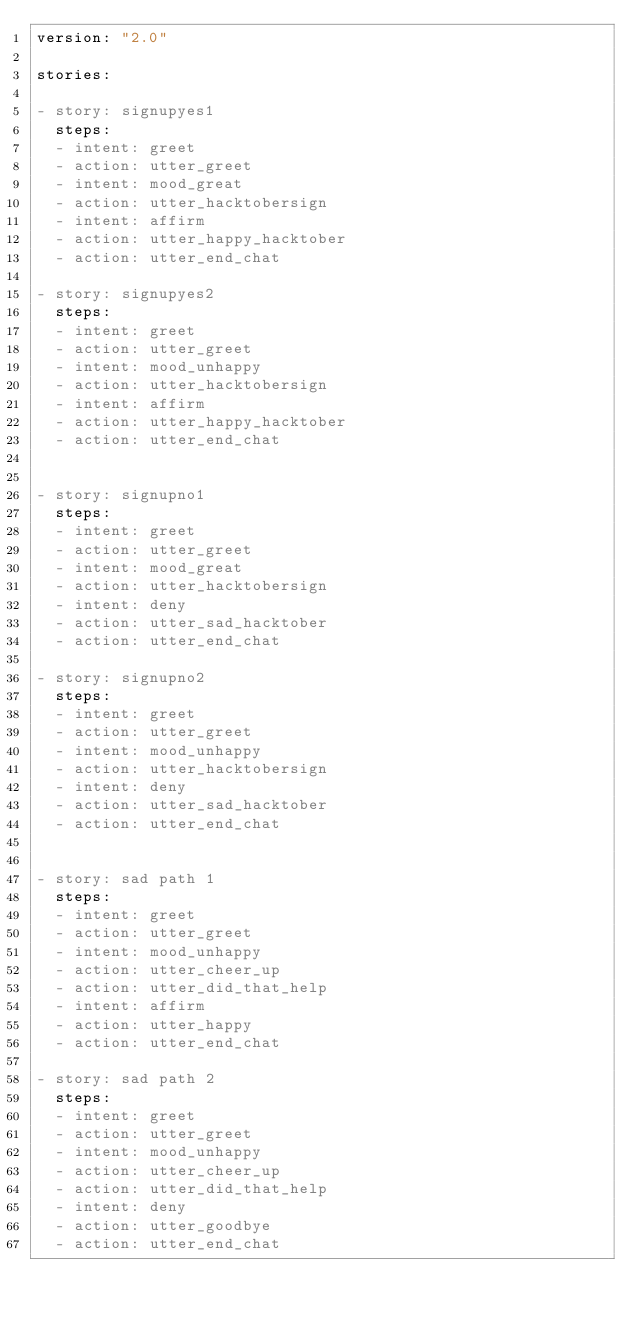<code> <loc_0><loc_0><loc_500><loc_500><_YAML_>version: "2.0"

stories:

- story: signupyes1
  steps:
  - intent: greet
  - action: utter_greet
  - intent: mood_great
  - action: utter_hacktobersign
  - intent: affirm
  - action: utter_happy_hacktober
  - action: utter_end_chat

- story: signupyes2
  steps:
  - intent: greet
  - action: utter_greet
  - intent: mood_unhappy
  - action: utter_hacktobersign
  - intent: affirm
  - action: utter_happy_hacktober
  - action: utter_end_chat


- story: signupno1
  steps:
  - intent: greet
  - action: utter_greet
  - intent: mood_great
  - action: utter_hacktobersign
  - intent: deny
  - action: utter_sad_hacktober
  - action: utter_end_chat

- story: signupno2
  steps:
  - intent: greet
  - action: utter_greet
  - intent: mood_unhappy
  - action: utter_hacktobersign
  - intent: deny
  - action: utter_sad_hacktober
  - action: utter_end_chat


- story: sad path 1
  steps:
  - intent: greet
  - action: utter_greet
  - intent: mood_unhappy
  - action: utter_cheer_up
  - action: utter_did_that_help
  - intent: affirm
  - action: utter_happy
  - action: utter_end_chat

- story: sad path 2
  steps:
  - intent: greet
  - action: utter_greet
  - intent: mood_unhappy
  - action: utter_cheer_up
  - action: utter_did_that_help
  - intent: deny
  - action: utter_goodbye
  - action: utter_end_chat
</code> 